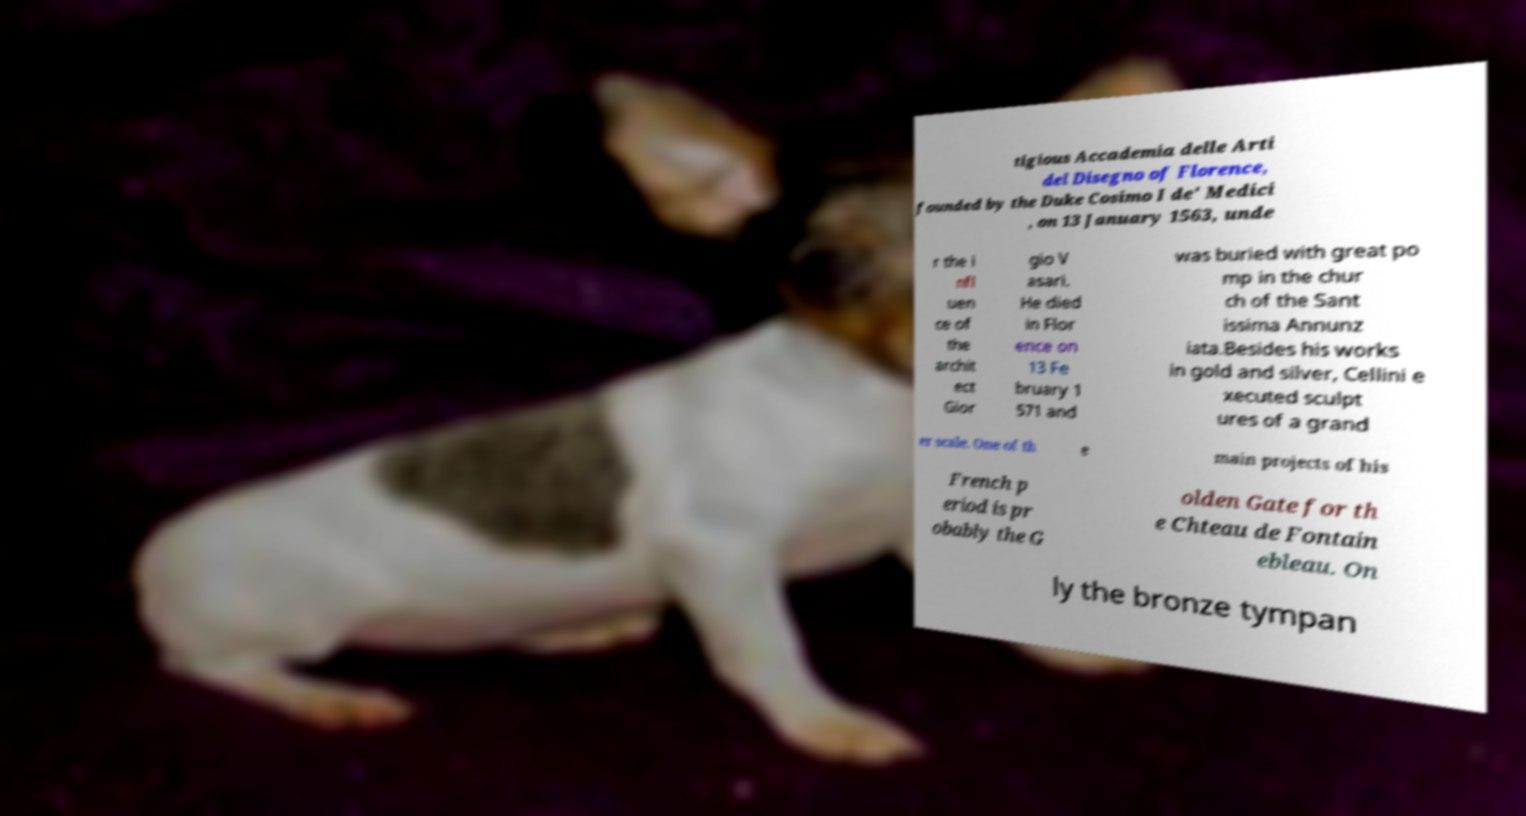There's text embedded in this image that I need extracted. Can you transcribe it verbatim? tigious Accademia delle Arti del Disegno of Florence, founded by the Duke Cosimo I de' Medici , on 13 January 1563, unde r the i nfl uen ce of the archit ect Gior gio V asari. He died in Flor ence on 13 Fe bruary 1 571 and was buried with great po mp in the chur ch of the Sant issima Annunz iata.Besides his works in gold and silver, Cellini e xecuted sculpt ures of a grand er scale. One of th e main projects of his French p eriod is pr obably the G olden Gate for th e Chteau de Fontain ebleau. On ly the bronze tympan 